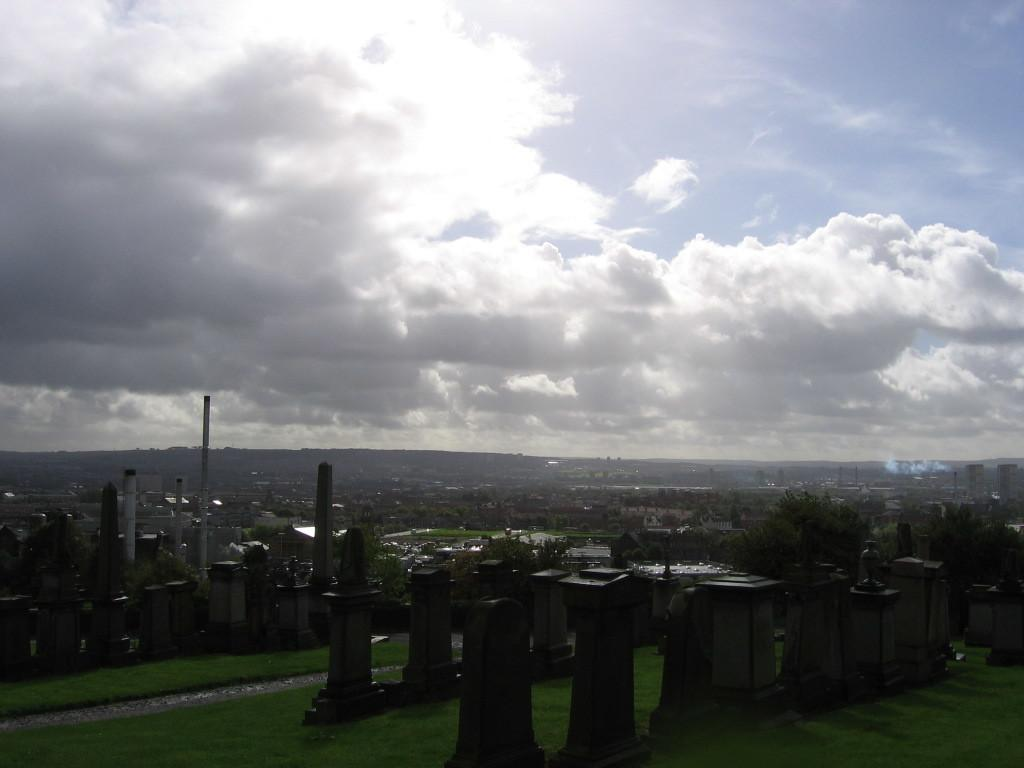What type of vegetation can be seen in the image? There are trees in the image. What architectural features are present in the image? There are pillars, buildings, and towers in the image. What other objects can be seen in the image? There are poles in the image. What is visible at the bottom of the image? The ground is visible at the bottom of the image. What is visible at the top of the image? The sky is visible at the top of the image. What is the cause of the love between the two men in the image? There are no men present in the image, and therefore no love or cause can be observed. 